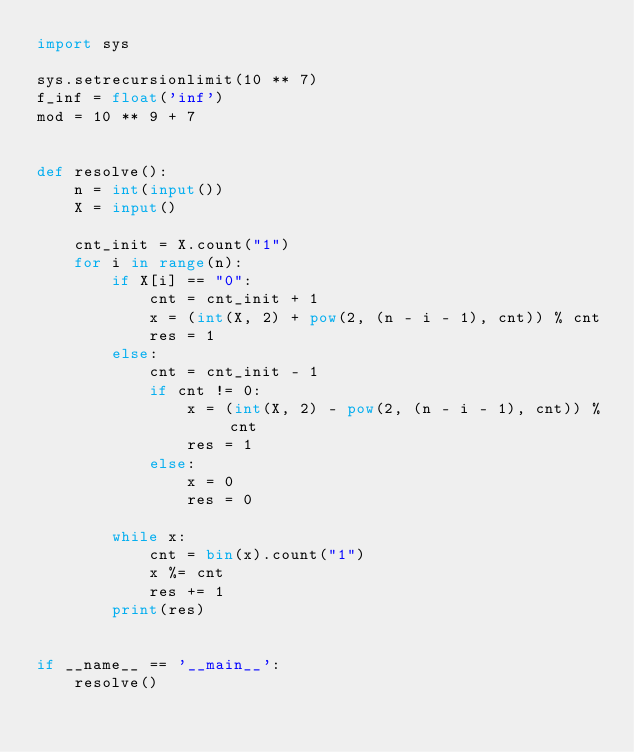Convert code to text. <code><loc_0><loc_0><loc_500><loc_500><_Python_>import sys

sys.setrecursionlimit(10 ** 7)
f_inf = float('inf')
mod = 10 ** 9 + 7


def resolve():
    n = int(input())
    X = input()

    cnt_init = X.count("1")
    for i in range(n):
        if X[i] == "0":
            cnt = cnt_init + 1
            x = (int(X, 2) + pow(2, (n - i - 1), cnt)) % cnt
            res = 1
        else:
            cnt = cnt_init - 1
            if cnt != 0:
                x = (int(X, 2) - pow(2, (n - i - 1), cnt)) % cnt
                res = 1
            else:
                x = 0
                res = 0

        while x:
            cnt = bin(x).count("1")
            x %= cnt
            res += 1
        print(res)


if __name__ == '__main__':
    resolve()
</code> 